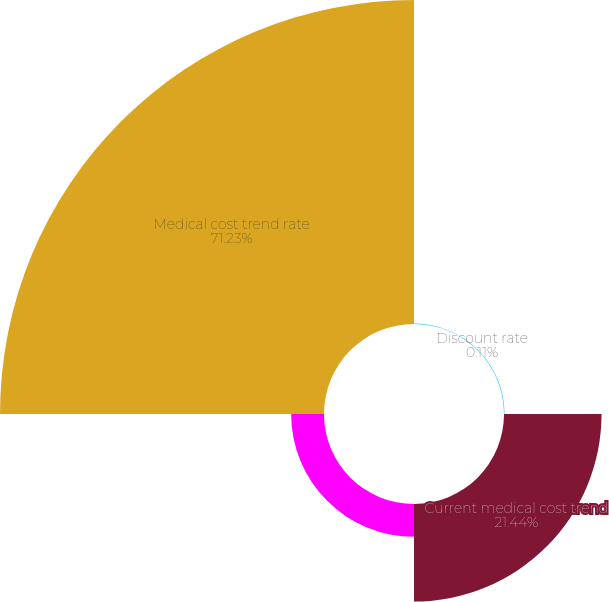Convert chart to OTSL. <chart><loc_0><loc_0><loc_500><loc_500><pie_chart><fcel>Discount rate<fcel>Current medical cost trend<fcel>Ultimate medical cost trend<fcel>Medical cost trend rate<nl><fcel>0.11%<fcel>21.44%<fcel>7.22%<fcel>71.22%<nl></chart> 